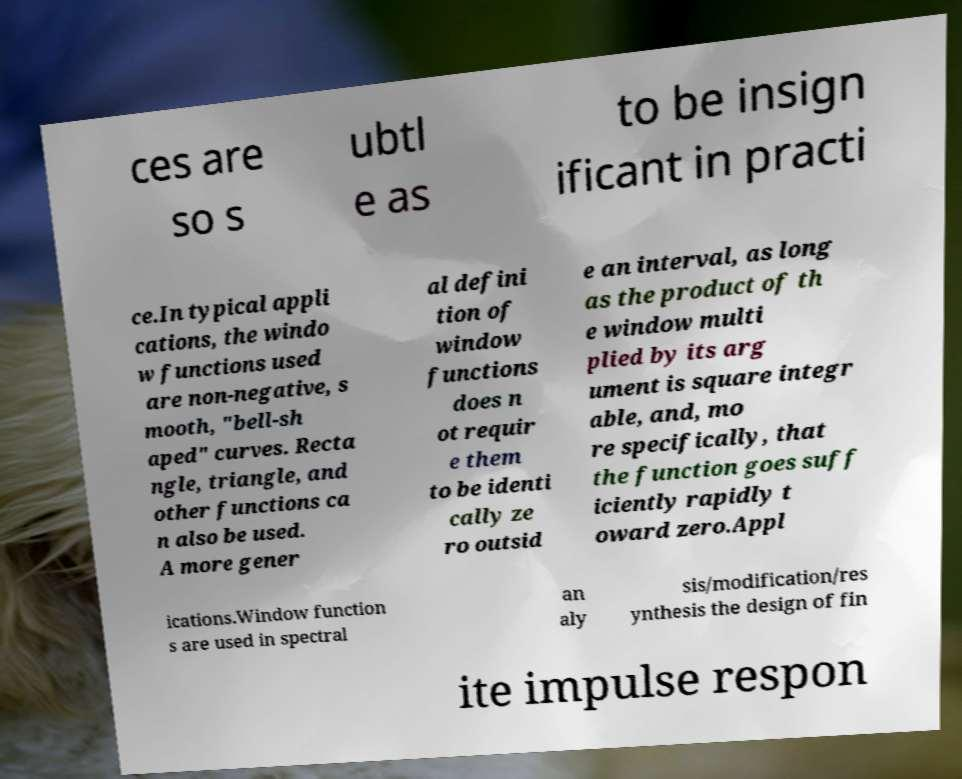I need the written content from this picture converted into text. Can you do that? ces are so s ubtl e as to be insign ificant in practi ce.In typical appli cations, the windo w functions used are non-negative, s mooth, "bell-sh aped" curves. Recta ngle, triangle, and other functions ca n also be used. A more gener al defini tion of window functions does n ot requir e them to be identi cally ze ro outsid e an interval, as long as the product of th e window multi plied by its arg ument is square integr able, and, mo re specifically, that the function goes suff iciently rapidly t oward zero.Appl ications.Window function s are used in spectral an aly sis/modification/res ynthesis the design of fin ite impulse respon 